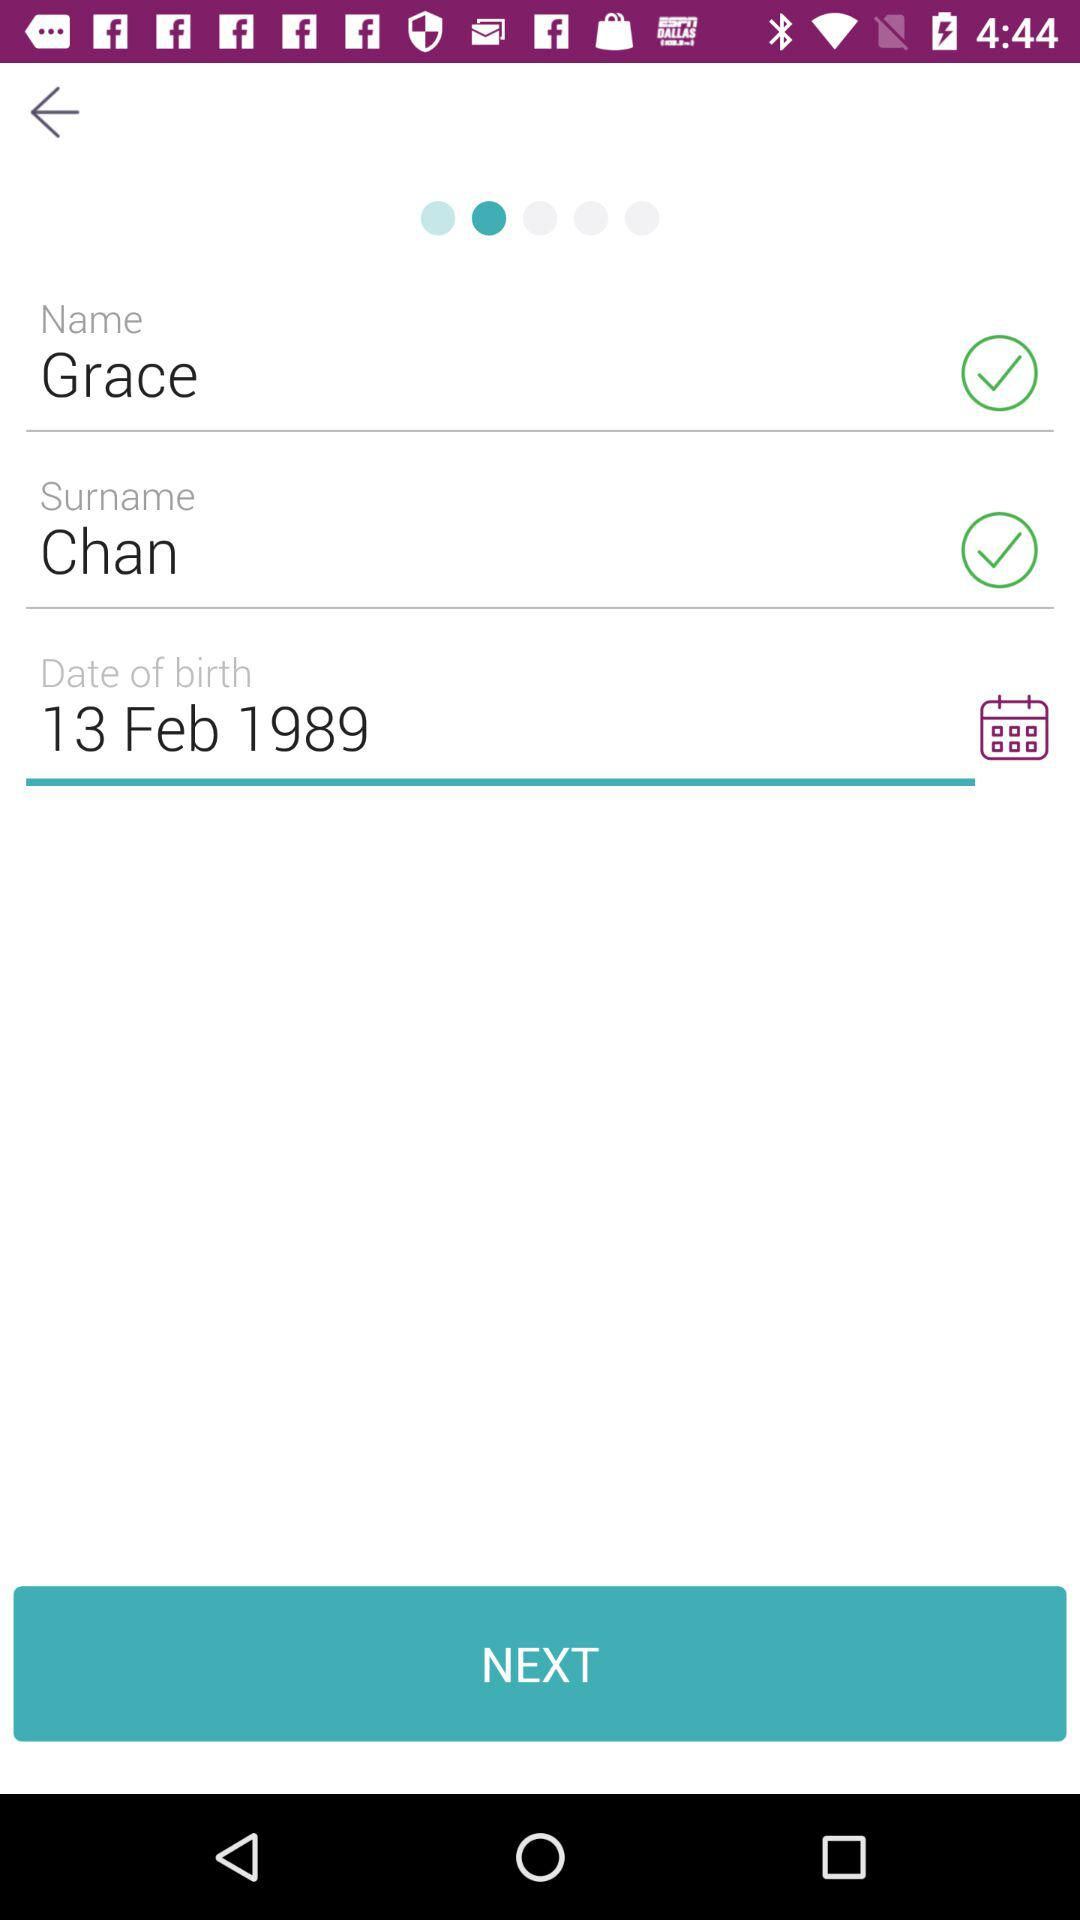What is the name of the user? The user name is Grace Chan. 